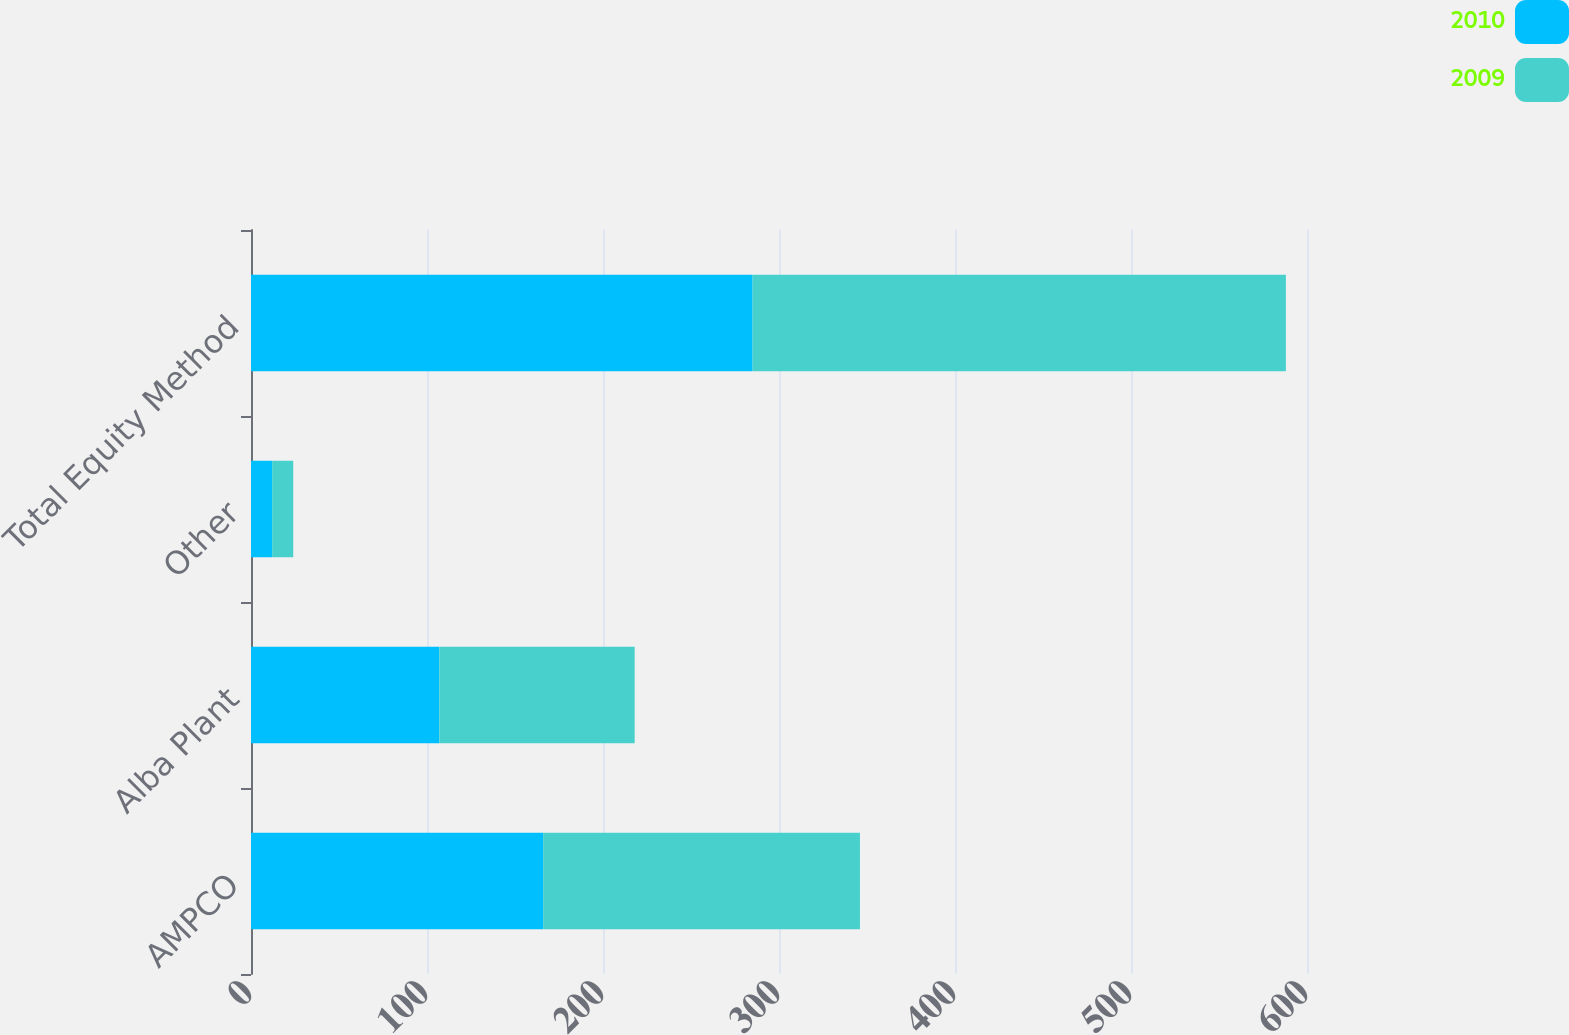Convert chart. <chart><loc_0><loc_0><loc_500><loc_500><stacked_bar_chart><ecel><fcel>AMPCO<fcel>Alba Plant<fcel>Other<fcel>Total Equity Method<nl><fcel>2010<fcel>166<fcel>107<fcel>12<fcel>285<nl><fcel>2009<fcel>180<fcel>111<fcel>12<fcel>303<nl></chart> 